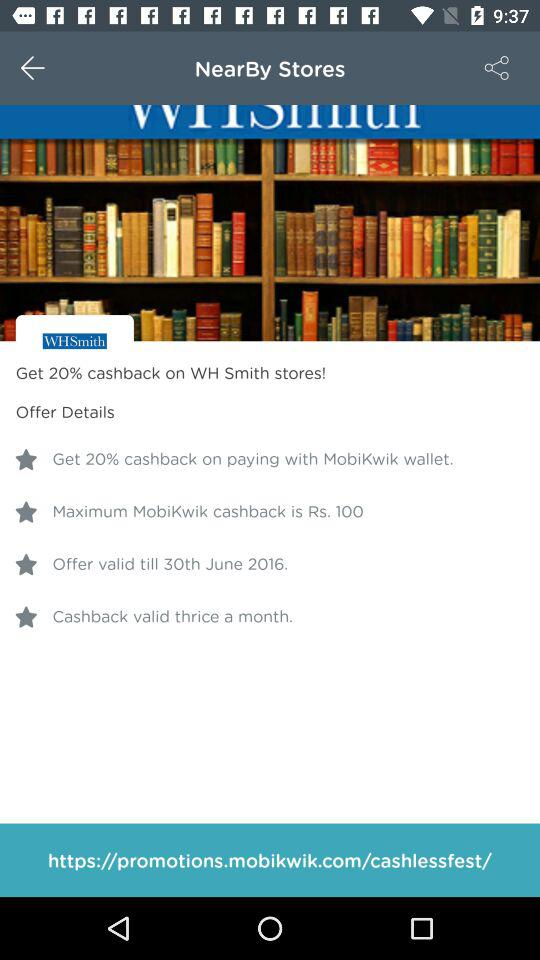What's the maximum "MobiKwik" cashback? The maximum cashback is Rs. 100. 